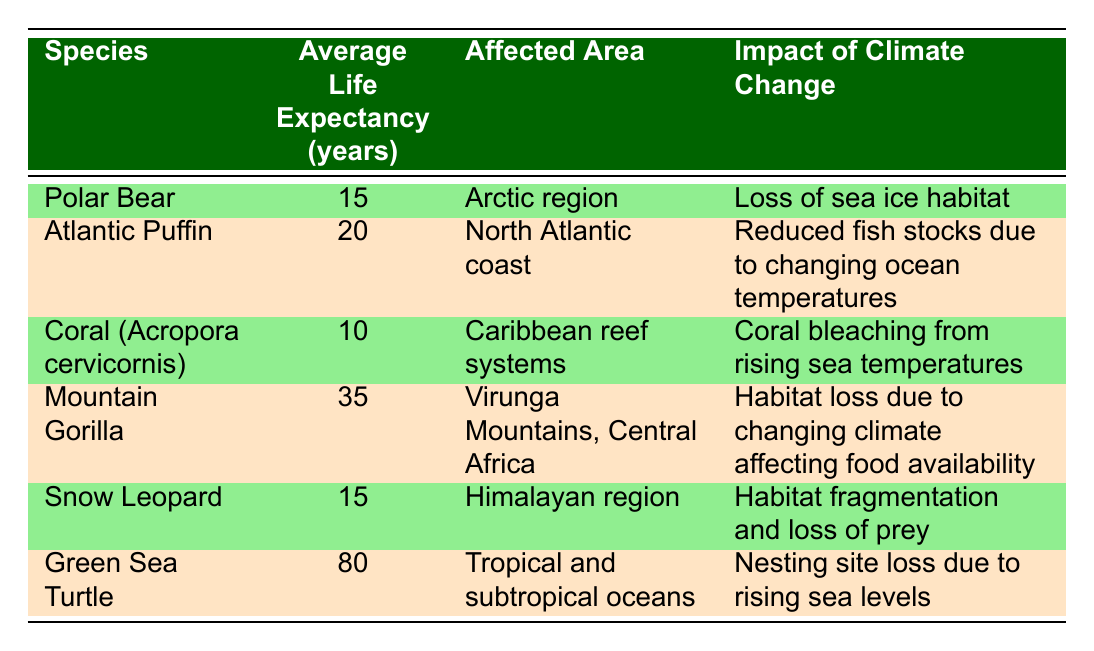What is the average life expectancy of a Polar Bear? The table shows that the Average Life Expectancy of a Polar Bear is 15 years, as indicated in the corresponding row for this species.
Answer: 15 years Which species has the longest average life expectancy? By comparing the Average Life Expectancy values, the Green Sea Turtle has the highest value at 80 years, making it the species with the longest average life expectancy.
Answer: Green Sea Turtle Is the average life expectancy of the Atlantic Puffin greater than 18? The Average Life Expectancy of the Atlantic Puffin is listed as 20 years, which is indeed greater than 18 years. Therefore, the answer is yes.
Answer: Yes How many species have an average life expectancy of 15 years? A careful count from the table shows that two species, the Polar Bear and the Snow Leopard, have an Average Life Expectancy of 15 years. Therefore, the total number is 2.
Answer: 2 What is the average life expectancy of species affected by habitat loss due to changing climate? To find this, we identify the species impacted by habitat loss: Mountain Gorilla (35 years) and Snow Leopard (15 years). The average is calculated as (35 + 15)/2 = 25 years.
Answer: 25 years Are there any species from the Arctic region listed in the table? The table indicates that the Polar Bear, which is from the Arctic region, is indeed present. Thus, the answer is yes.
Answer: Yes What is the difference in average life expectancy between the Green Sea Turtle and Coral? The average life expectancy of the Green Sea Turtle is 80 years, while Coral's is 10. The difference is calculated by subtracting 10 from 80, resulting in 70 years.
Answer: 70 years Which species is affected by coral bleaching? According to the table, Coral (Acropora cervicornis) is specifically listed and described as being affected by coral bleaching from rising sea temperatures.
Answer: Coral (Acropora cervicornis) How many species are affected by reduced food availability? The only species mentioned in relation to reduced food availability due to climate change is the Mountain Gorilla. Therefore, the answer is 1.
Answer: 1 